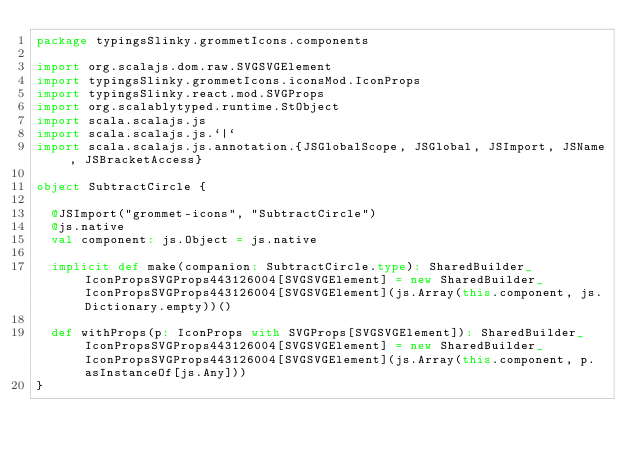Convert code to text. <code><loc_0><loc_0><loc_500><loc_500><_Scala_>package typingsSlinky.grommetIcons.components

import org.scalajs.dom.raw.SVGSVGElement
import typingsSlinky.grommetIcons.iconsMod.IconProps
import typingsSlinky.react.mod.SVGProps
import org.scalablytyped.runtime.StObject
import scala.scalajs.js
import scala.scalajs.js.`|`
import scala.scalajs.js.annotation.{JSGlobalScope, JSGlobal, JSImport, JSName, JSBracketAccess}

object SubtractCircle {
  
  @JSImport("grommet-icons", "SubtractCircle")
  @js.native
  val component: js.Object = js.native
  
  implicit def make(companion: SubtractCircle.type): SharedBuilder_IconPropsSVGProps443126004[SVGSVGElement] = new SharedBuilder_IconPropsSVGProps443126004[SVGSVGElement](js.Array(this.component, js.Dictionary.empty))()
  
  def withProps(p: IconProps with SVGProps[SVGSVGElement]): SharedBuilder_IconPropsSVGProps443126004[SVGSVGElement] = new SharedBuilder_IconPropsSVGProps443126004[SVGSVGElement](js.Array(this.component, p.asInstanceOf[js.Any]))
}
</code> 